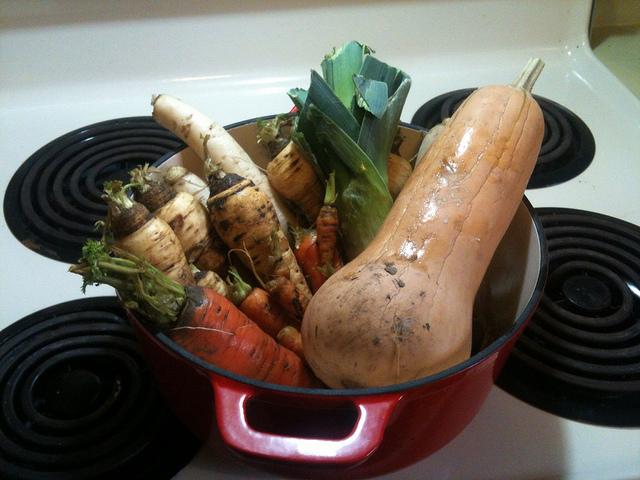What green vegetable is in the pot?
Give a very brief answer. Leek. Did these vegetables just come out of the garden?
Quick response, please. Yes. Are the vegetables cooking?
Quick response, please. No. Where will cook need to put the pot to cook vegetables?
Write a very short answer. Stove. 